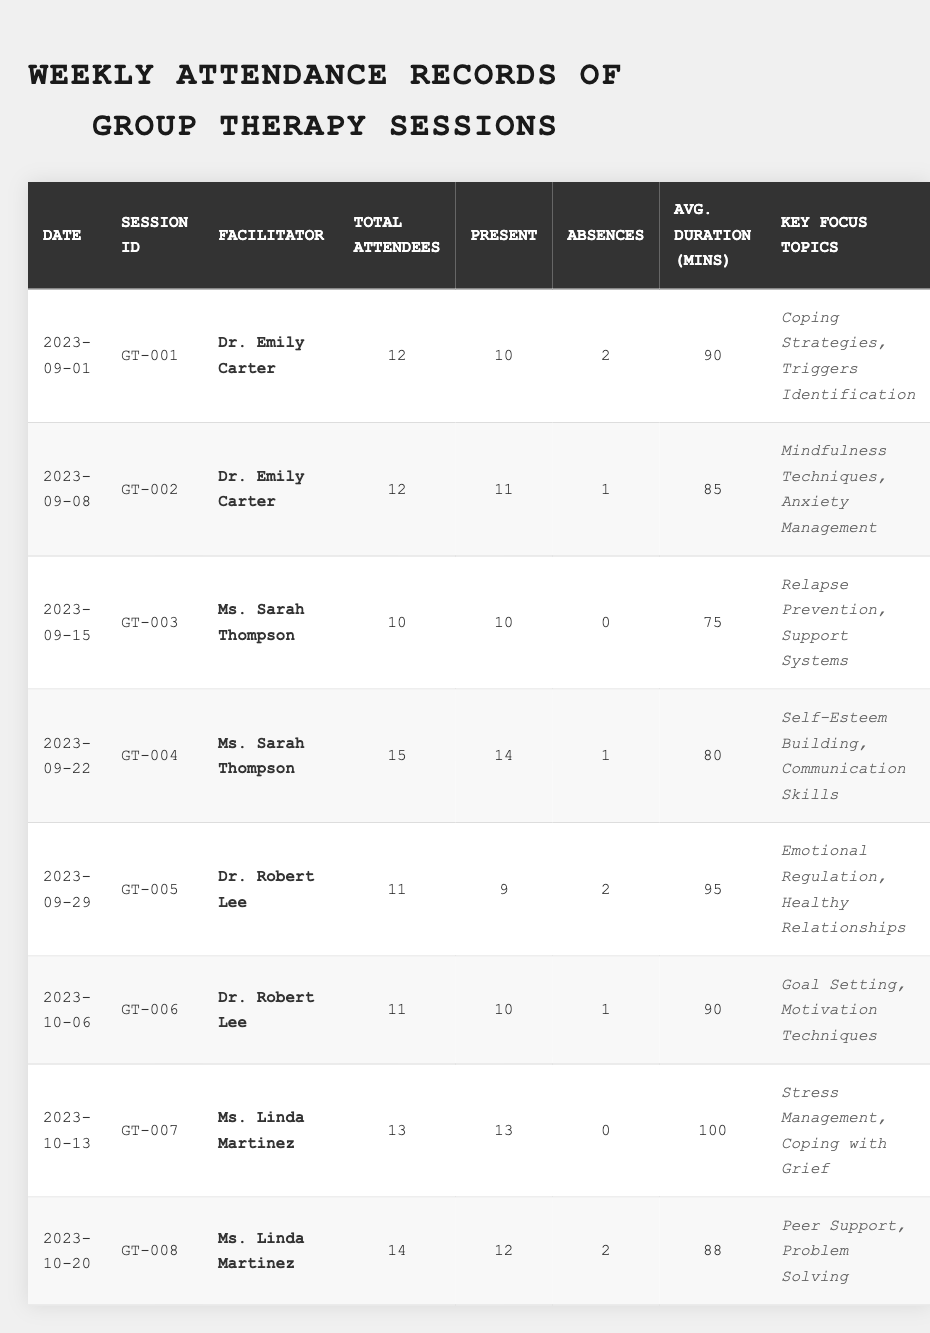What was the total number of absences across all sessions? There are 8 entries in the table for absences: 2, 1, 0, 1, 2, 1, 0, and 2. Summing these gives 2 + 1 + 0 + 1 + 2 + 1 + 0 + 2 = 9.
Answer: 9 Who facilitated the session on 2023-10-13? Looking at the table for the date 2023-10-13, the facilitator listed is "Ms. Linda Martinez."
Answer: Ms. Linda Martinez What was the average attendance for the sessions facilitated by Dr. Robert Lee? Counting the total present for Dr. Robert Lee's sessions: 9 (GT-005) + 10 (GT-006) = 19. The number of these sessions is 2, so the average attendance is 19 / 2 = 9.5.
Answer: 9.5 Did any session have all attendees present? Checking each session’s "Present" column, the sessions on 2023-09-15 and 2023-10-13 both had total attendees equal to the number present, meaning no absences. Thus, yes, there were sessions with all attendees present.
Answer: Yes What are the key focus topics for the session with the highest average duration? The longest average duration is 100 minutes for the session on 2023-10-13, which focuses on "Stress Management, Coping with Grief."
Answer: Stress Management, Coping with Grief Which session had the highest number of absences, and how many were there? Looking through the absences listed in the table, the highest number of absences is 2, found in sessions on 2023-09-01, 2023-09-29, and 2023-10-20. So, there are three sessions with that number of absences, namely GT-001, GT-005, and GT-008.
Answer: GT-001, GT-005, GT-008 (2 absences) What is the average duration of the sessions that had less than 90 minutes of average duration? The sessions with less than 90 minutes of average duration are: GT-003 (75 mins), and GT-008 (88 mins). The total duration for these is 75 + 88 = 163 for 2 sessions, so the average is 163 / 2 = 81.5 minutes.
Answer: 81.5 Compare the total number of attendees for sessions facilitated by Dr. Emily Carter and Ms. Sarah Thompson. Dr. Emily Carter had a total of 12 + 12 = 24 attendees over 2 sessions, while Ms. Sarah Thompson had 10 + 15 = 25 attendees over 2 sessions. Comparing these totals, Ms. Sarah Thompson had 1 more attendee than Dr. Emily Carter.
Answer: Ms. Sarah Thompson (25), Dr. Emily Carter (24) How many sessions focused on "Coping Strategies"? Looking at the "Key Focus Topics" column, there is one session, on 2023-09-01 (GT-001), that mentioned "Coping Strategies."
Answer: 1 Which session had the least number of attendees, and how many were there? The session on 2023-09-15 had the fewest total attendees listed at 10.
Answer: GT-003 (10 attendees) What is the overall attendance rate (percentage of Present) for all sessions? The total attendance across all sessions is calculated as follows: Present (10 + 11 + 10 + 14 + 9 + 10 + 13 + 12) = 99, and Total attendees (12 + 12 + 10 + 15 + 11 + 11 + 13 + 14) =  88. The attendance rate is then (99 / 88) * 100 ≈ 112.5%.
Answer: 112.5% 